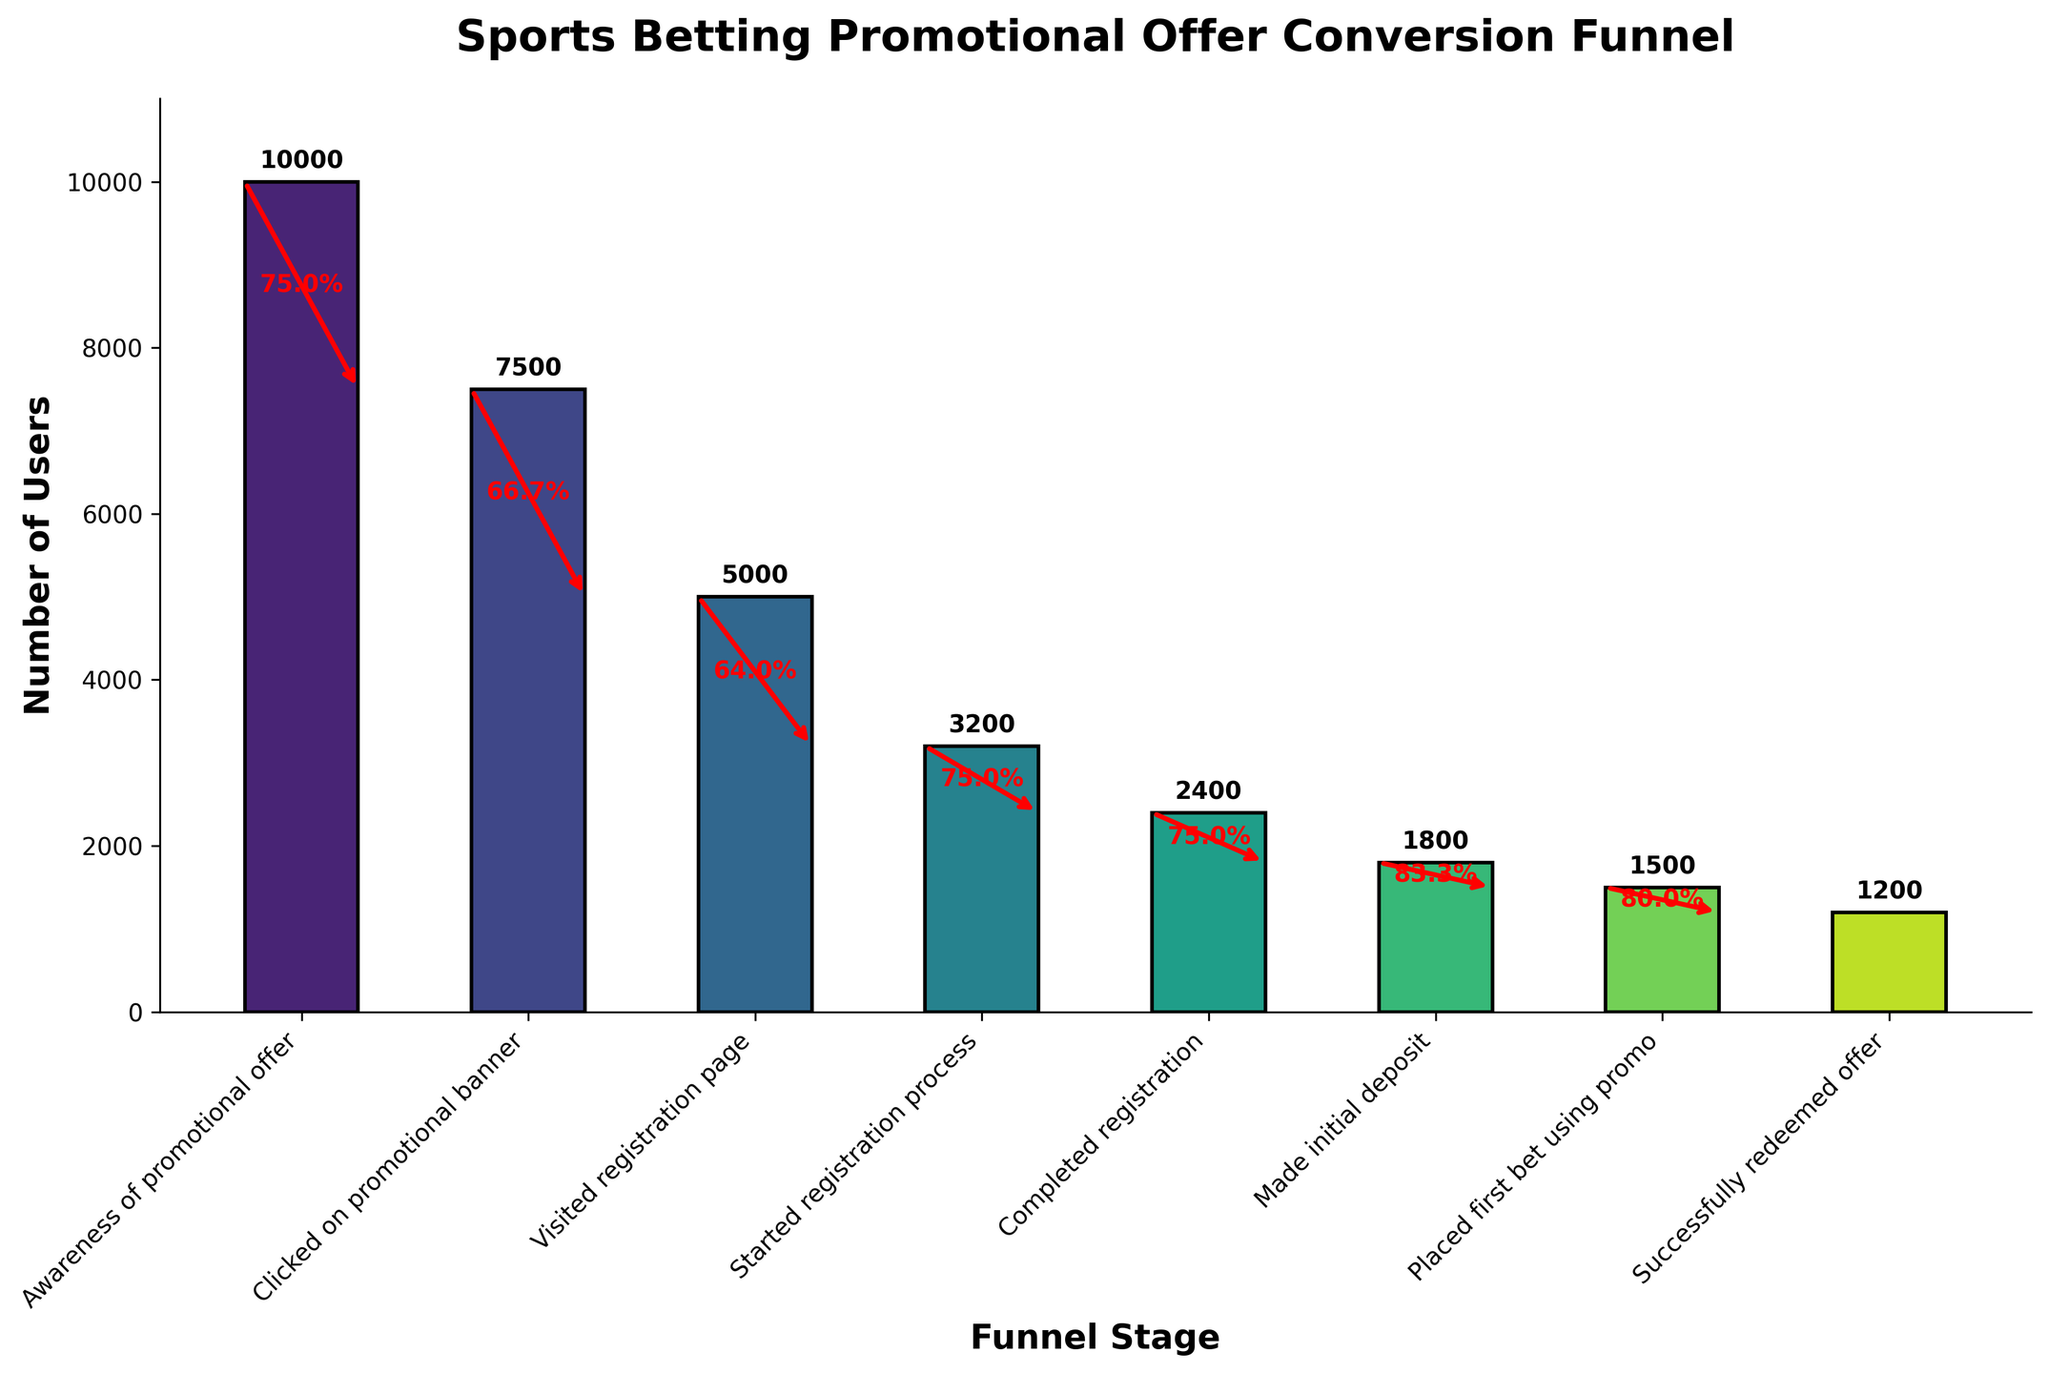What's the title of the chart? The title is located at the top of the chart, often in larger and bold font, indicating the overall content of the figure.
Answer: Sports Betting Promotional Offer Conversion Funnel What does the y-axis represent? Observing the label on the y-axis, we see it typically describes what is being measured in the data across different stages.
Answer: Number of Users Which stage has the highest number of users? The bar chart's height correlates with the number of users; the stage with the tallest bar indicates the highest number of users.
Answer: Awareness of promotional offer How many users clicked on the promotional banner? Refer to the height of the bar corresponding to the stage "Clicked on promotional banner" and the label above it.
Answer: 7500 What is the percentage drop from the 'Awareness of promotional offer' to 'Clicked on promotional banner'? Calculate the percentage as (Users who clicked on the banner / Users aware of the promotional offer) * 100, which corresponds to the annotation on the figure. (7500 / 10000) * 100 = 75%
Answer: 75% How many users completed the registration process? Check the bar's label and height for the stage "Completed registration" to find the exact number of users at this stage.
Answer: 2400 What is the percentage conversion from 'Completed registration' to 'Made initial deposit'? Use the number of users at these stages to find the conversion percentage, calculated as (Users who made an initial deposit / Users who completed registration) * 100, and referencing the annotation. (1800/2400) * 100 = 75%
Answer: 75% Which stage has the least number of users? Identify the shortest bar in the funnel chart, which represents the stage with the fewest users.
Answer: Successfully redeemed offer What's the difference in user count between 'Started registration process' and 'Completed registration'? Subtract the number of users in the "Completed registration" stage from those in the "Started registration process" stage. 3200 - 2400 = 800
Answer: 800 What is the overall percentage of users who successfully redeemed the offer from those who were aware of the promotional offer? Calculate the final conversion percentage from the initial number of users aware of the offer to those who successfully redeemed it, given by (1200/10000) * 100.
Answer: 12% 